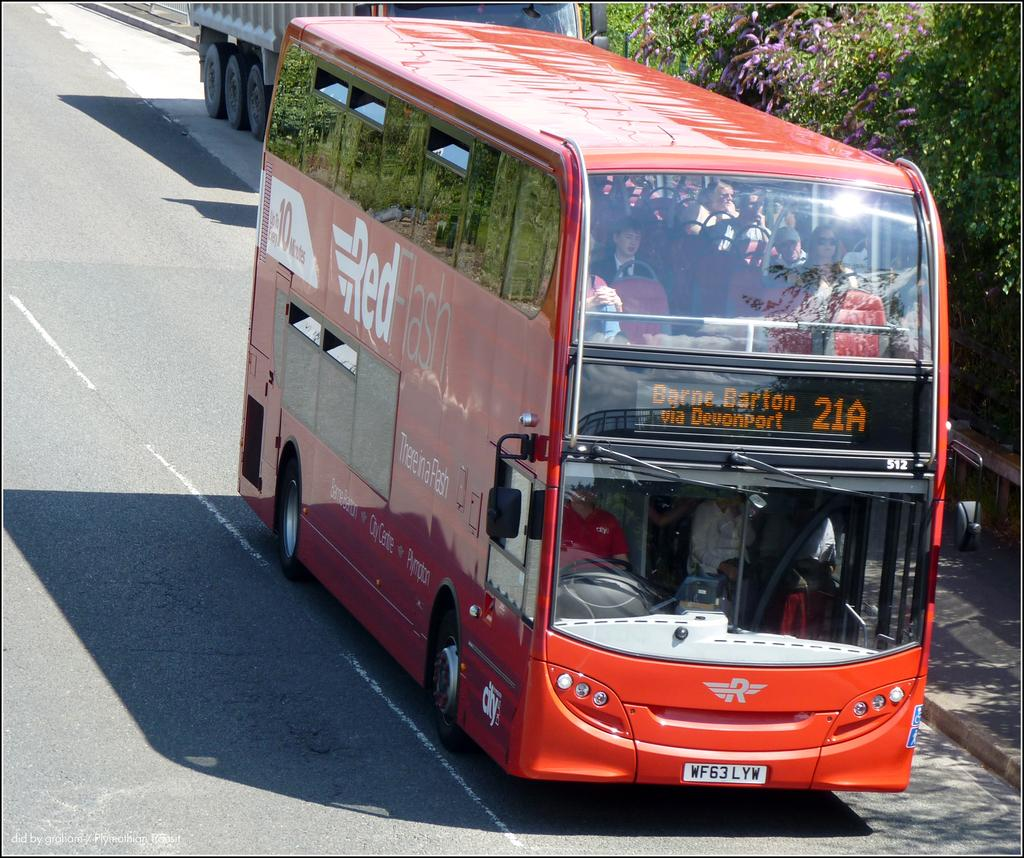What type of vehicle is in the middle of the road in the image? There is a bus on the road in the image. Can you describe the vehicle behind the bus? There is another vehicle behind the bus. What is located on the right side of the image? There is a footpath and trees on the right side of the image. Can you see a bridge crossing the sea in the image? There is no bridge or sea present in the image. 